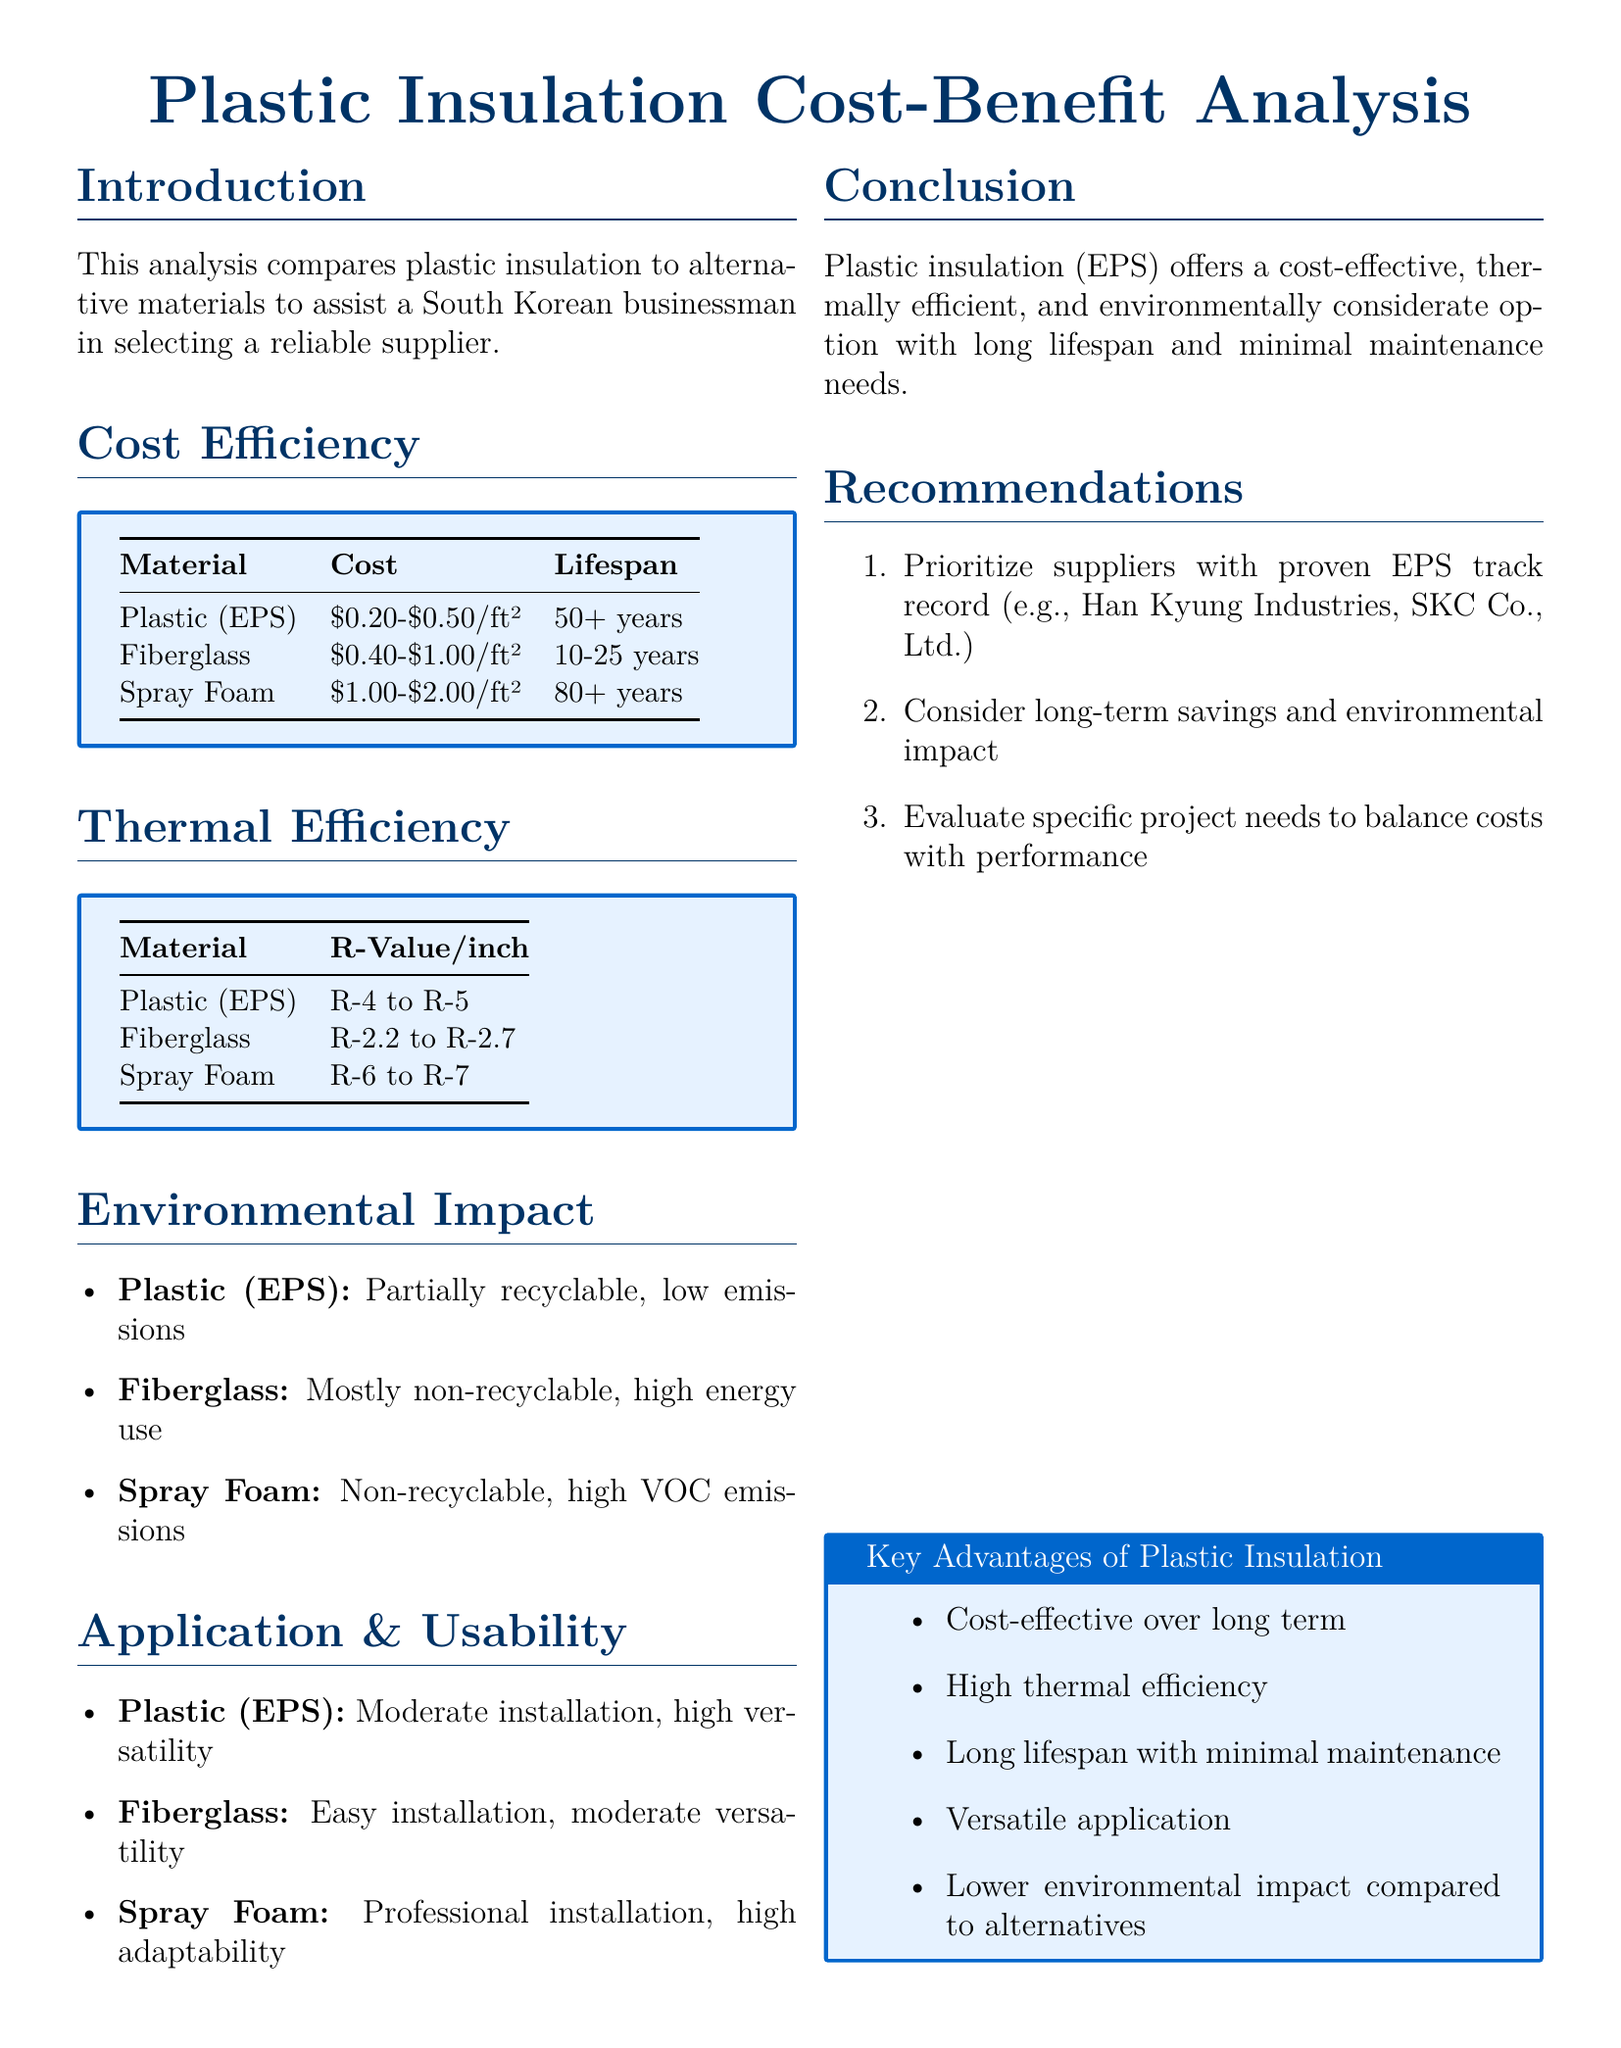What is the cost range for Plastic (EPS) insulation? The cost range for Plastic (EPS) insulation is listed in the Cost Efficiency section of the document as \$0.20-\$0.50/ft².
Answer: \$0.20-\$0.50/ft² What is the R-Value per inch for Spray Foam insulation? The R-Value for Spray Foam insulation is found in the Thermal Efficiency section and is R-6 to R-7.
Answer: R-6 to R-7 Which insulation material has the longest lifespan? The lifespan of various materials is compared in the Cost Efficiency section, where Spray Foam is stated to have a lifespan of 80+ years.
Answer: Spray Foam What is stated about the recyclability of Fiberglass insulation? The Environmental Impact section mentions that Fiberglass insulation is mostly non-recyclable.
Answer: Mostly non-recyclable What recommendation is made regarding suppliers for EPS insulation? The recommendations in the Recommendations section mention prioritizing suppliers with a proven EPS track record, such as Han Kyung Industries.
Answer: Han Kyung Industries How does the thermal efficiency of Plastic (EPS) compare to Fiberglass? The document indicates in the Thermal Efficiency section that Plastic (EPS) has a higher R-Value (R-4 to R-5) compared to Fiberglass (R-2.2 to R-2.7).
Answer: Higher R-Value What is the environmental impact of Plastic (EPS)? The Environmental Impact section describes Plastic (EPS) as partially recyclable with low emissions.
Answer: Partially recyclable, low emissions What is a key advantage of Plastic insulation mentioned in the document? The Key Advantages section lists several benefits, including being cost-effective over the long term.
Answer: Cost-effective over long term 